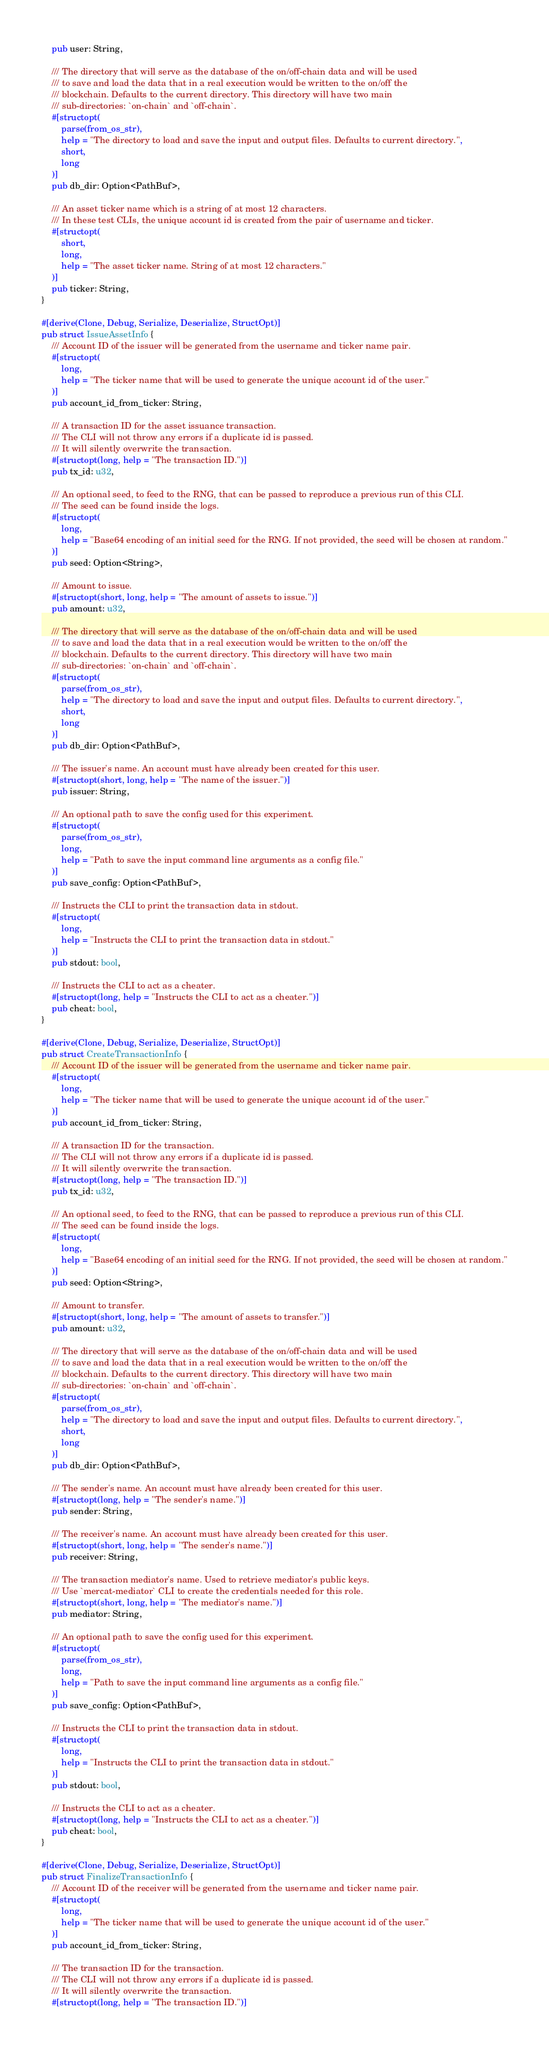Convert code to text. <code><loc_0><loc_0><loc_500><loc_500><_Rust_>    pub user: String,

    /// The directory that will serve as the database of the on/off-chain data and will be used
    /// to save and load the data that in a real execution would be written to the on/off the
    /// blockchain. Defaults to the current directory. This directory will have two main
    /// sub-directories: `on-chain` and `off-chain`.
    #[structopt(
        parse(from_os_str),
        help = "The directory to load and save the input and output files. Defaults to current directory.",
        short,
        long
    )]
    pub db_dir: Option<PathBuf>,

    /// An asset ticker name which is a string of at most 12 characters.
    /// In these test CLIs, the unique account id is created from the pair of username and ticker.
    #[structopt(
        short,
        long,
        help = "The asset ticker name. String of at most 12 characters."
    )]
    pub ticker: String,
}

#[derive(Clone, Debug, Serialize, Deserialize, StructOpt)]
pub struct IssueAssetInfo {
    /// Account ID of the issuer will be generated from the username and ticker name pair.
    #[structopt(
        long,
        help = "The ticker name that will be used to generate the unique account id of the user."
    )]
    pub account_id_from_ticker: String,

    /// A transaction ID for the asset issuance transaction.
    /// The CLI will not throw any errors if a duplicate id is passed.
    /// It will silently overwrite the transaction.
    #[structopt(long, help = "The transaction ID.")]
    pub tx_id: u32,

    /// An optional seed, to feed to the RNG, that can be passed to reproduce a previous run of this CLI.
    /// The seed can be found inside the logs.
    #[structopt(
        long,
        help = "Base64 encoding of an initial seed for the RNG. If not provided, the seed will be chosen at random."
    )]
    pub seed: Option<String>,

    /// Amount to issue.
    #[structopt(short, long, help = "The amount of assets to issue.")]
    pub amount: u32,

    /// The directory that will serve as the database of the on/off-chain data and will be used
    /// to save and load the data that in a real execution would be written to the on/off the
    /// blockchain. Defaults to the current directory. This directory will have two main
    /// sub-directories: `on-chain` and `off-chain`.
    #[structopt(
        parse(from_os_str),
        help = "The directory to load and save the input and output files. Defaults to current directory.",
        short,
        long
    )]
    pub db_dir: Option<PathBuf>,

    /// The issuer's name. An account must have already been created for this user.
    #[structopt(short, long, help = "The name of the issuer.")]
    pub issuer: String,

    /// An optional path to save the config used for this experiment.
    #[structopt(
        parse(from_os_str),
        long,
        help = "Path to save the input command line arguments as a config file."
    )]
    pub save_config: Option<PathBuf>,

    /// Instructs the CLI to print the transaction data in stdout.
    #[structopt(
        long,
        help = "Instructs the CLI to print the transaction data in stdout."
    )]
    pub stdout: bool,

    /// Instructs the CLI to act as a cheater.
    #[structopt(long, help = "Instructs the CLI to act as a cheater.")]
    pub cheat: bool,
}

#[derive(Clone, Debug, Serialize, Deserialize, StructOpt)]
pub struct CreateTransactionInfo {
    /// Account ID of the issuer will be generated from the username and ticker name pair.
    #[structopt(
        long,
        help = "The ticker name that will be used to generate the unique account id of the user."
    )]
    pub account_id_from_ticker: String,

    /// A transaction ID for the transaction.
    /// The CLI will not throw any errors if a duplicate id is passed.
    /// It will silently overwrite the transaction.
    #[structopt(long, help = "The transaction ID.")]
    pub tx_id: u32,

    /// An optional seed, to feed to the RNG, that can be passed to reproduce a previous run of this CLI.
    /// The seed can be found inside the logs.
    #[structopt(
        long,
        help = "Base64 encoding of an initial seed for the RNG. If not provided, the seed will be chosen at random."
    )]
    pub seed: Option<String>,

    /// Amount to transfer.
    #[structopt(short, long, help = "The amount of assets to transfer.")]
    pub amount: u32,

    /// The directory that will serve as the database of the on/off-chain data and will be used
    /// to save and load the data that in a real execution would be written to the on/off the
    /// blockchain. Defaults to the current directory. This directory will have two main
    /// sub-directories: `on-chain` and `off-chain`.
    #[structopt(
        parse(from_os_str),
        help = "The directory to load and save the input and output files. Defaults to current directory.",
        short,
        long
    )]
    pub db_dir: Option<PathBuf>,

    /// The sender's name. An account must have already been created for this user.
    #[structopt(long, help = "The sender's name.")]
    pub sender: String,

    /// The receiver's name. An account must have already been created for this user.
    #[structopt(short, long, help = "The sender's name.")]
    pub receiver: String,

    /// The transaction mediator's name. Used to retrieve mediator's public keys.
    /// Use `mercat-mediator` CLI to create the credentials needed for this role.
    #[structopt(short, long, help = "The mediator's name.")]
    pub mediator: String,

    /// An optional path to save the config used for this experiment.
    #[structopt(
        parse(from_os_str),
        long,
        help = "Path to save the input command line arguments as a config file."
    )]
    pub save_config: Option<PathBuf>,

    /// Instructs the CLI to print the transaction data in stdout.
    #[structopt(
        long,
        help = "Instructs the CLI to print the transaction data in stdout."
    )]
    pub stdout: bool,

    /// Instructs the CLI to act as a cheater.
    #[structopt(long, help = "Instructs the CLI to act as a cheater.")]
    pub cheat: bool,
}

#[derive(Clone, Debug, Serialize, Deserialize, StructOpt)]
pub struct FinalizeTransactionInfo {
    /// Account ID of the receiver will be generated from the username and ticker name pair.
    #[structopt(
        long,
        help = "The ticker name that will be used to generate the unique account id of the user."
    )]
    pub account_id_from_ticker: String,

    /// The transaction ID for the transaction.
    /// The CLI will not throw any errors if a duplicate id is passed.
    /// It will silently overwrite the transaction.
    #[structopt(long, help = "The transaction ID.")]</code> 